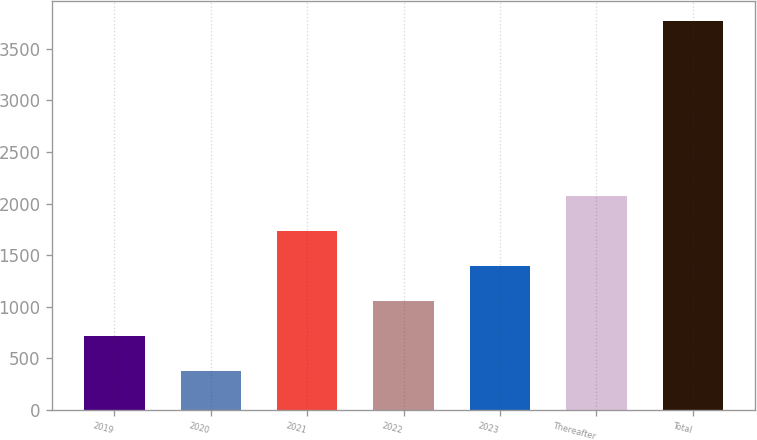<chart> <loc_0><loc_0><loc_500><loc_500><bar_chart><fcel>2019<fcel>2020<fcel>2021<fcel>2022<fcel>2023<fcel>Thereafter<fcel>Total<nl><fcel>720.17<fcel>380.9<fcel>1737.98<fcel>1059.44<fcel>1398.71<fcel>2077.25<fcel>3773.6<nl></chart> 